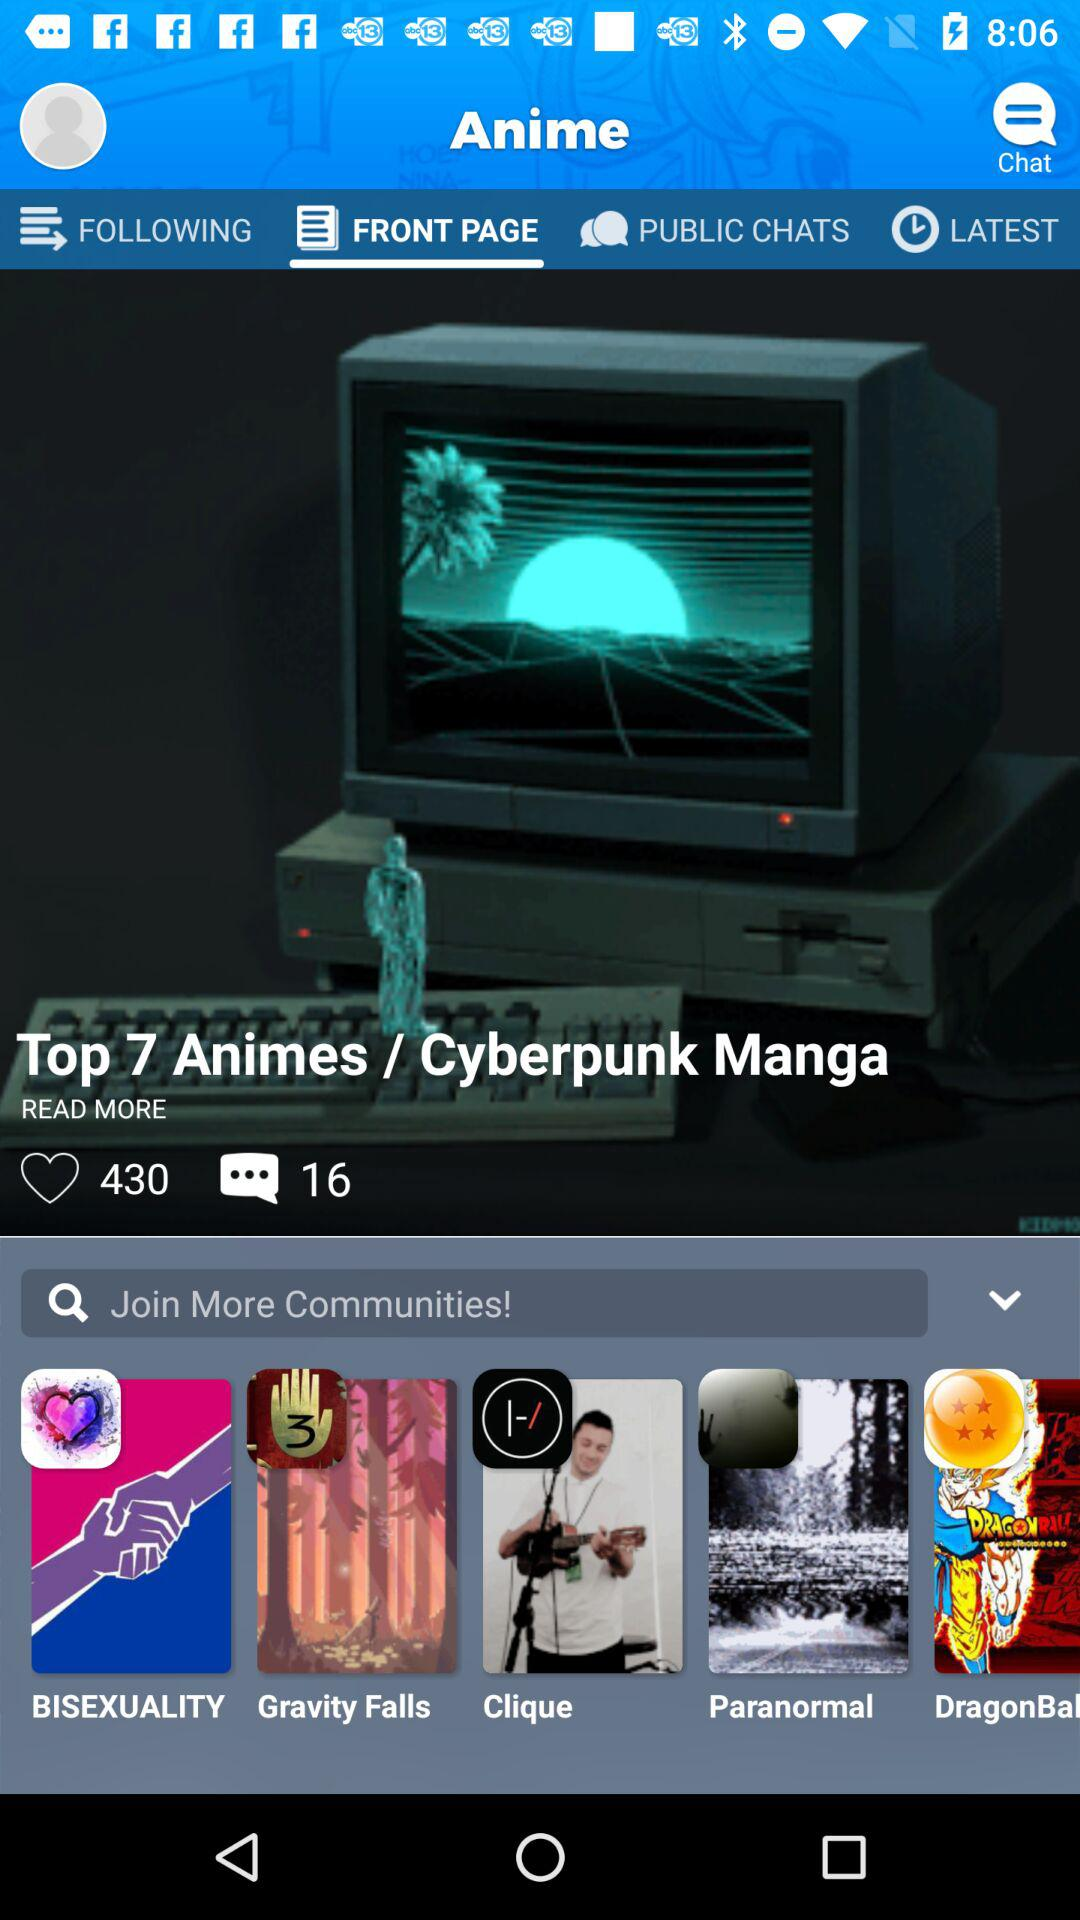What is the total number of messages? The total number of messages is 16. 